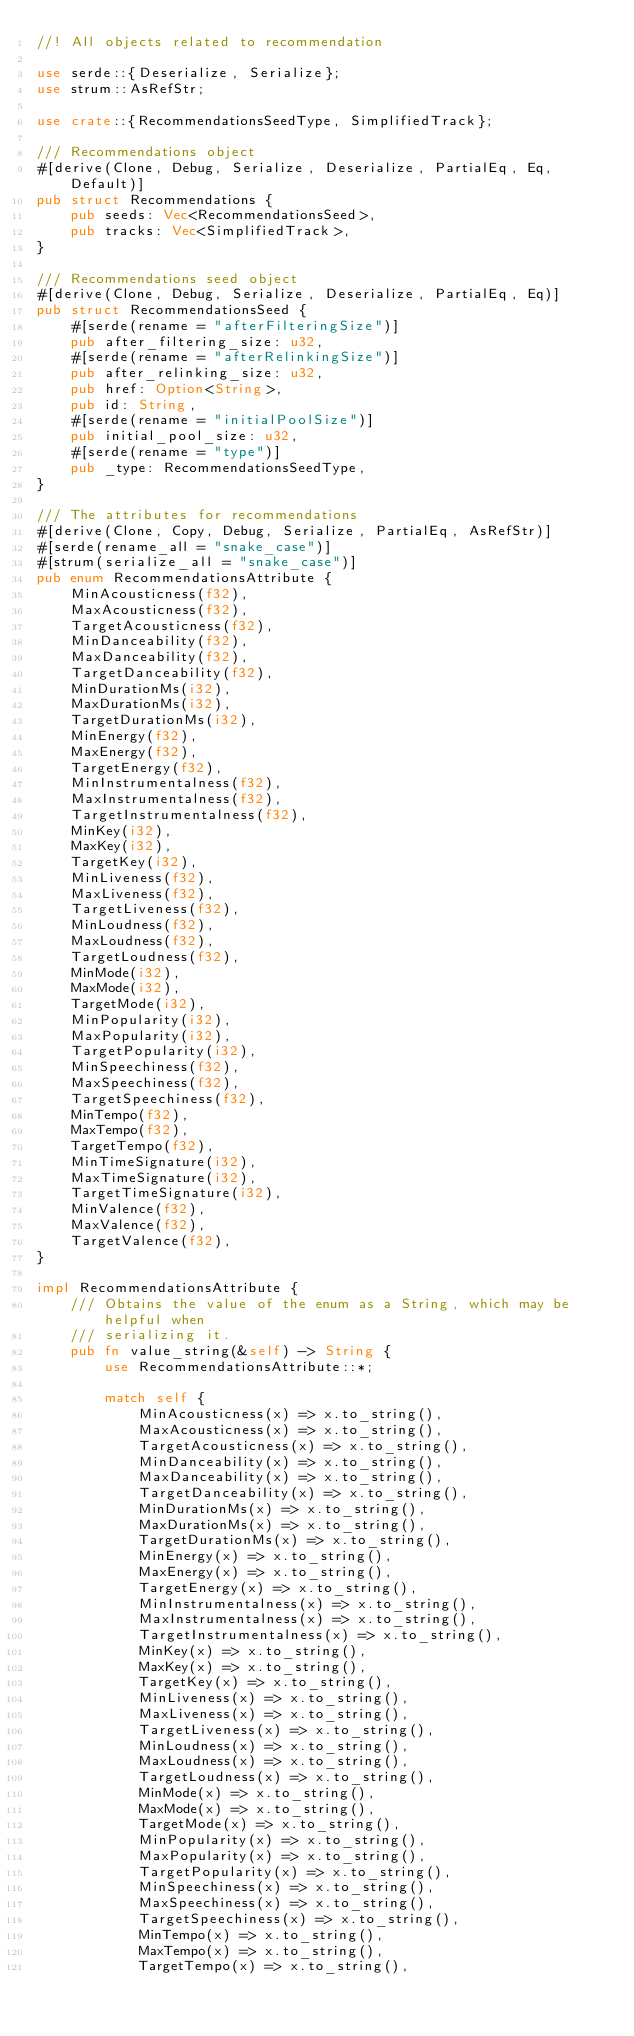Convert code to text. <code><loc_0><loc_0><loc_500><loc_500><_Rust_>//! All objects related to recommendation

use serde::{Deserialize, Serialize};
use strum::AsRefStr;

use crate::{RecommendationsSeedType, SimplifiedTrack};

/// Recommendations object
#[derive(Clone, Debug, Serialize, Deserialize, PartialEq, Eq, Default)]
pub struct Recommendations {
    pub seeds: Vec<RecommendationsSeed>,
    pub tracks: Vec<SimplifiedTrack>,
}

/// Recommendations seed object
#[derive(Clone, Debug, Serialize, Deserialize, PartialEq, Eq)]
pub struct RecommendationsSeed {
    #[serde(rename = "afterFilteringSize")]
    pub after_filtering_size: u32,
    #[serde(rename = "afterRelinkingSize")]
    pub after_relinking_size: u32,
    pub href: Option<String>,
    pub id: String,
    #[serde(rename = "initialPoolSize")]
    pub initial_pool_size: u32,
    #[serde(rename = "type")]
    pub _type: RecommendationsSeedType,
}

/// The attributes for recommendations
#[derive(Clone, Copy, Debug, Serialize, PartialEq, AsRefStr)]
#[serde(rename_all = "snake_case")]
#[strum(serialize_all = "snake_case")]
pub enum RecommendationsAttribute {
    MinAcousticness(f32),
    MaxAcousticness(f32),
    TargetAcousticness(f32),
    MinDanceability(f32),
    MaxDanceability(f32),
    TargetDanceability(f32),
    MinDurationMs(i32),
    MaxDurationMs(i32),
    TargetDurationMs(i32),
    MinEnergy(f32),
    MaxEnergy(f32),
    TargetEnergy(f32),
    MinInstrumentalness(f32),
    MaxInstrumentalness(f32),
    TargetInstrumentalness(f32),
    MinKey(i32),
    MaxKey(i32),
    TargetKey(i32),
    MinLiveness(f32),
    MaxLiveness(f32),
    TargetLiveness(f32),
    MinLoudness(f32),
    MaxLoudness(f32),
    TargetLoudness(f32),
    MinMode(i32),
    MaxMode(i32),
    TargetMode(i32),
    MinPopularity(i32),
    MaxPopularity(i32),
    TargetPopularity(i32),
    MinSpeechiness(f32),
    MaxSpeechiness(f32),
    TargetSpeechiness(f32),
    MinTempo(f32),
    MaxTempo(f32),
    TargetTempo(f32),
    MinTimeSignature(i32),
    MaxTimeSignature(i32),
    TargetTimeSignature(i32),
    MinValence(f32),
    MaxValence(f32),
    TargetValence(f32),
}

impl RecommendationsAttribute {
    /// Obtains the value of the enum as a String, which may be helpful when
    /// serializing it.
    pub fn value_string(&self) -> String {
        use RecommendationsAttribute::*;

        match self {
            MinAcousticness(x) => x.to_string(),
            MaxAcousticness(x) => x.to_string(),
            TargetAcousticness(x) => x.to_string(),
            MinDanceability(x) => x.to_string(),
            MaxDanceability(x) => x.to_string(),
            TargetDanceability(x) => x.to_string(),
            MinDurationMs(x) => x.to_string(),
            MaxDurationMs(x) => x.to_string(),
            TargetDurationMs(x) => x.to_string(),
            MinEnergy(x) => x.to_string(),
            MaxEnergy(x) => x.to_string(),
            TargetEnergy(x) => x.to_string(),
            MinInstrumentalness(x) => x.to_string(),
            MaxInstrumentalness(x) => x.to_string(),
            TargetInstrumentalness(x) => x.to_string(),
            MinKey(x) => x.to_string(),
            MaxKey(x) => x.to_string(),
            TargetKey(x) => x.to_string(),
            MinLiveness(x) => x.to_string(),
            MaxLiveness(x) => x.to_string(),
            TargetLiveness(x) => x.to_string(),
            MinLoudness(x) => x.to_string(),
            MaxLoudness(x) => x.to_string(),
            TargetLoudness(x) => x.to_string(),
            MinMode(x) => x.to_string(),
            MaxMode(x) => x.to_string(),
            TargetMode(x) => x.to_string(),
            MinPopularity(x) => x.to_string(),
            MaxPopularity(x) => x.to_string(),
            TargetPopularity(x) => x.to_string(),
            MinSpeechiness(x) => x.to_string(),
            MaxSpeechiness(x) => x.to_string(),
            TargetSpeechiness(x) => x.to_string(),
            MinTempo(x) => x.to_string(),
            MaxTempo(x) => x.to_string(),
            TargetTempo(x) => x.to_string(),</code> 